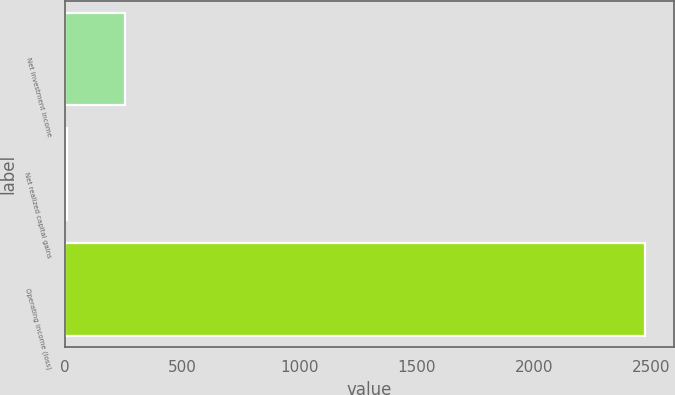Convert chart to OTSL. <chart><loc_0><loc_0><loc_500><loc_500><bar_chart><fcel>Net investment income<fcel>Net realized capital gains<fcel>Operating income (loss)<nl><fcel>253.8<fcel>7<fcel>2475<nl></chart> 